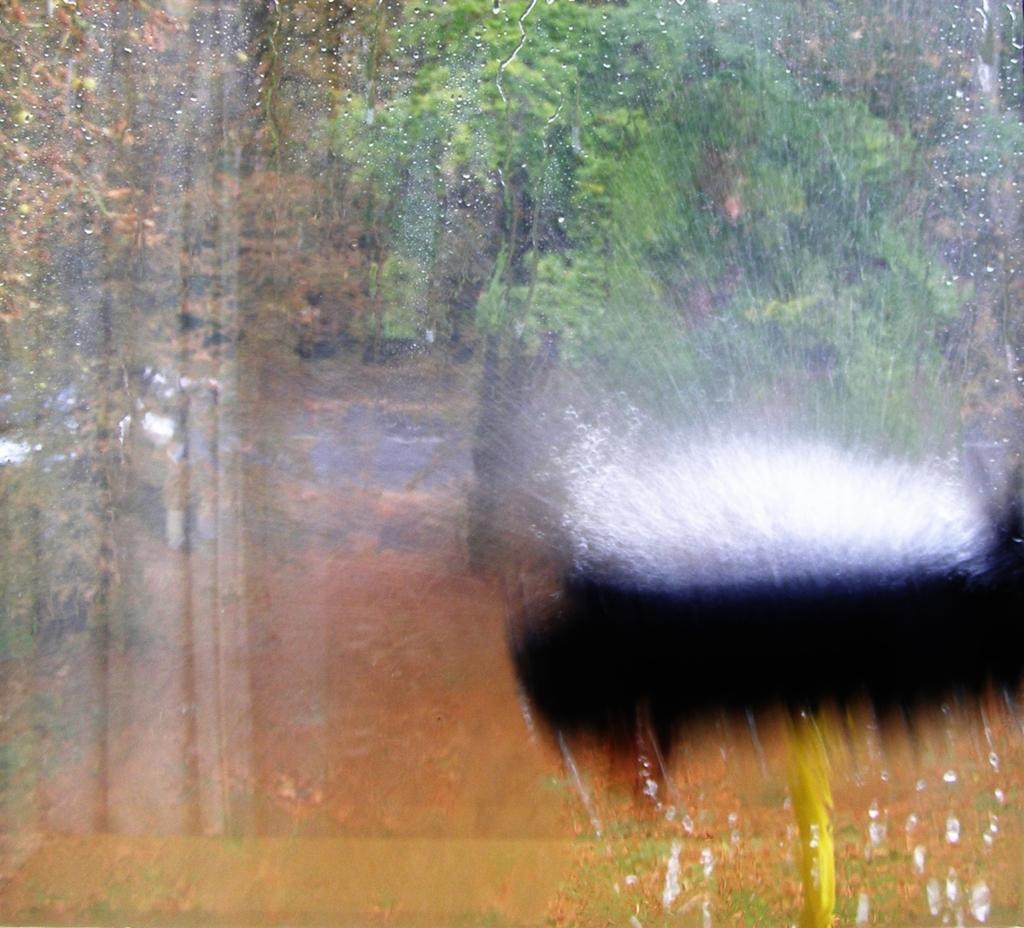Please provide a concise description of this image. In this picture the image is blur. In the background of the image we can see some trees. 